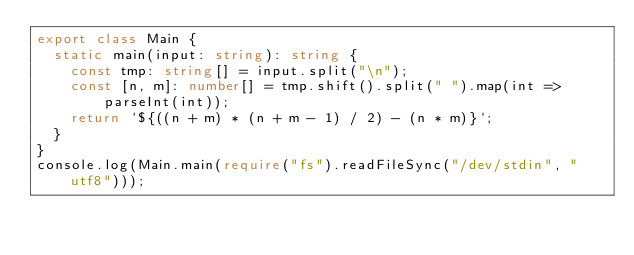<code> <loc_0><loc_0><loc_500><loc_500><_TypeScript_>export class Main {
  static main(input: string): string {
    const tmp: string[] = input.split("\n");
    const [n, m]: number[] = tmp.shift().split(" ").map(int => parseInt(int));
    return `${((n + m) * (n + m - 1) / 2) - (n * m)}`;
  }
}
console.log(Main.main(require("fs").readFileSync("/dev/stdin", "utf8")));
</code> 